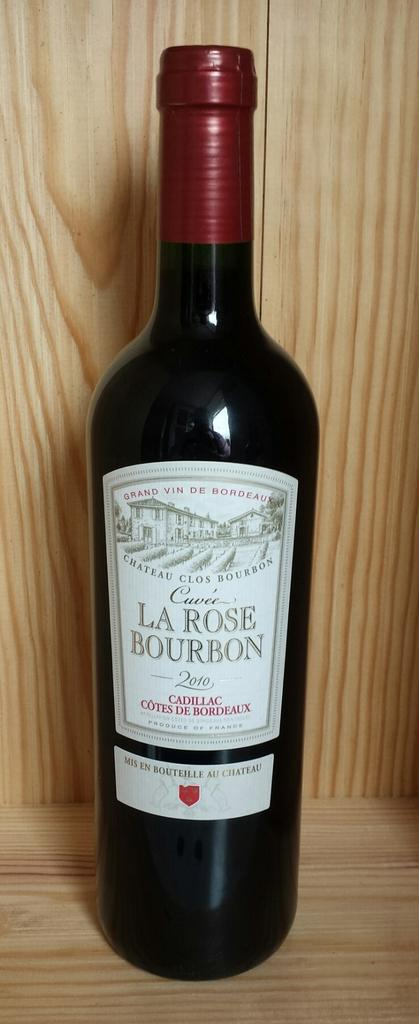Provide a one-sentence caption for the provided image. bottle of 2010 la rose bourbon on a wooden shelf. 